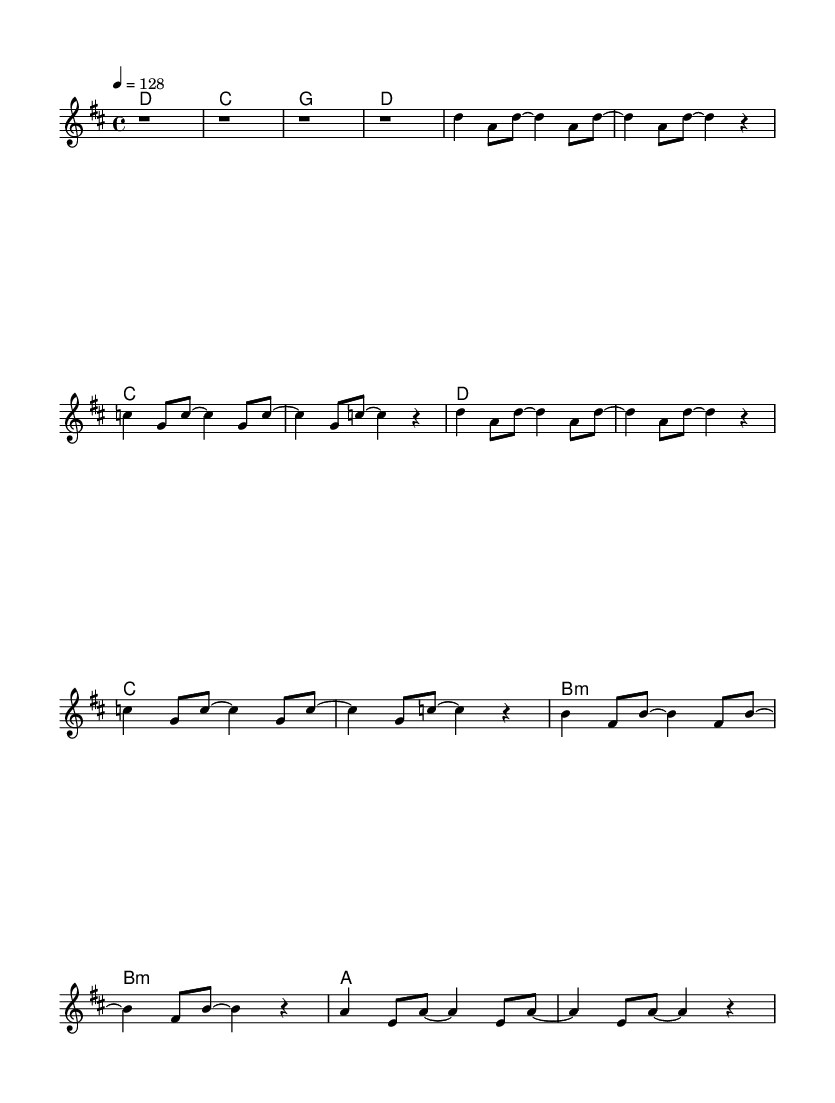What is the key signature of this music? The key signature is D major, which has two sharps (F# and C#). This can be identified by looking for the key signature at the beginning of the sheet music, right after the clef symbol.
Answer: D major What is the time signature of this music? The time signature is 4/4, which indicates that there are four beats per measure and a quarter note receives one beat. This can be seen at the beginning of the sheet music notation.
Answer: 4/4 What is the tempo marking? The tempo marking is 128 beats per minute. This indicates the speed at which the piece should be played and can be found next to the tempo indication in the music sheet.
Answer: 128 How many measures are there in the sheet music? There are 16 measures in total. This can be counted by observing the grouping of notes and rests, and identifying where each measure ends according to the 4/4 time signature.
Answer: 16 What chord does the music start with? The music starts with a D major chord. This can be determined by looking at the chord names written above the staff notation at the beginning of the music.
Answer: D What is the structure of this music piece? The structure includes an Intro, Verse 1, Chorus, and Bridge. This can be inferred from the way the music is divided into distinct sections, indicated by the varying musical phrases and the organization of the notes and chords.
Answer: Intro, Verse 1, Chorus, Bridge Which K-Pop traits could be seen in this musical style? The K-Pop traits observable in this style include repetitive melodies and strong hooks, which are characteristic of many K-Pop songs, aimed at maintaining listener engagement. This can be interpreted from the repetitive chorus and catchy melodic phrases contained within the sheet music.
Answer: Repetitive melodies and strong hooks 